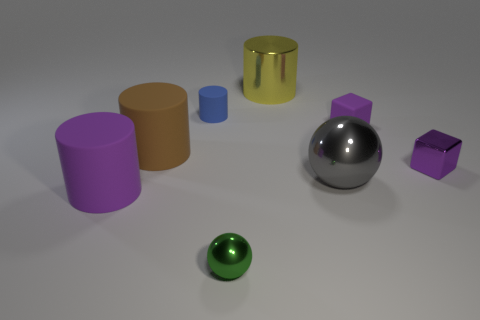Subtract all purple cylinders. How many cylinders are left? 3 Subtract 2 cylinders. How many cylinders are left? 2 Add 1 purple metal balls. How many objects exist? 9 Subtract all yellow cylinders. How many cylinders are left? 3 Subtract all gray cylinders. Subtract all gray cubes. How many cylinders are left? 4 Add 5 tiny blue rubber cylinders. How many tiny blue rubber cylinders exist? 6 Subtract 0 gray cubes. How many objects are left? 8 Subtract all cylinders. Subtract all small gray cylinders. How many objects are left? 4 Add 5 small purple metallic blocks. How many small purple metallic blocks are left? 6 